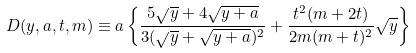Convert formula to latex. <formula><loc_0><loc_0><loc_500><loc_500>D ( y , a , t , m ) \equiv a \left \{ \frac { 5 \sqrt { y } + 4 \sqrt { y + a } } { 3 ( \sqrt { y } + \sqrt { y + a } ) ^ { 2 } } + \frac { t ^ { 2 } ( m + 2 t ) } { 2 m ( m + t ) ^ { 2 } } \sqrt { y } \right \}</formula> 